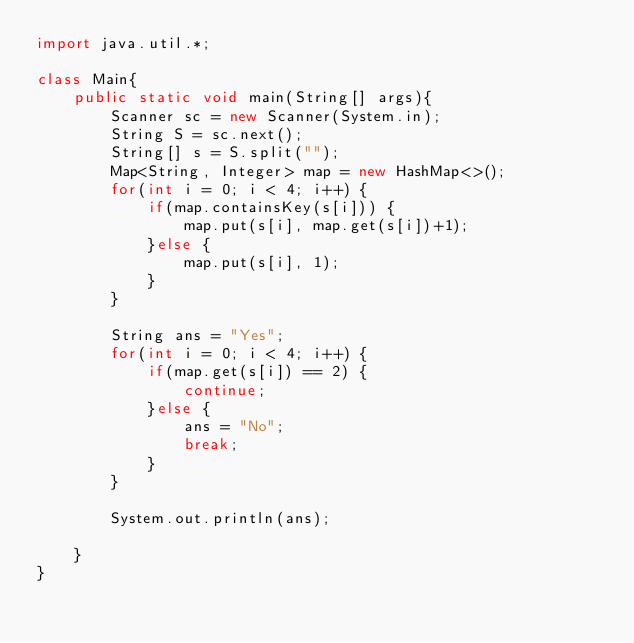Convert code to text. <code><loc_0><loc_0><loc_500><loc_500><_Java_>import java.util.*;

class Main{
    public static void main(String[] args){
        Scanner sc = new Scanner(System.in);
        String S = sc.next();
        String[] s = S.split("");
        Map<String, Integer> map = new HashMap<>();
        for(int i = 0; i < 4; i++) {
            if(map.containsKey(s[i])) {
                map.put(s[i], map.get(s[i])+1);
            }else {
                map.put(s[i], 1);
            }
        }
        
        String ans = "Yes";
        for(int i = 0; i < 4; i++) {
            if(map.get(s[i]) == 2) {
                continue;
            }else {
                ans = "No";
                break;
            }
        }
        
        System.out.println(ans);
        
    }
}</code> 